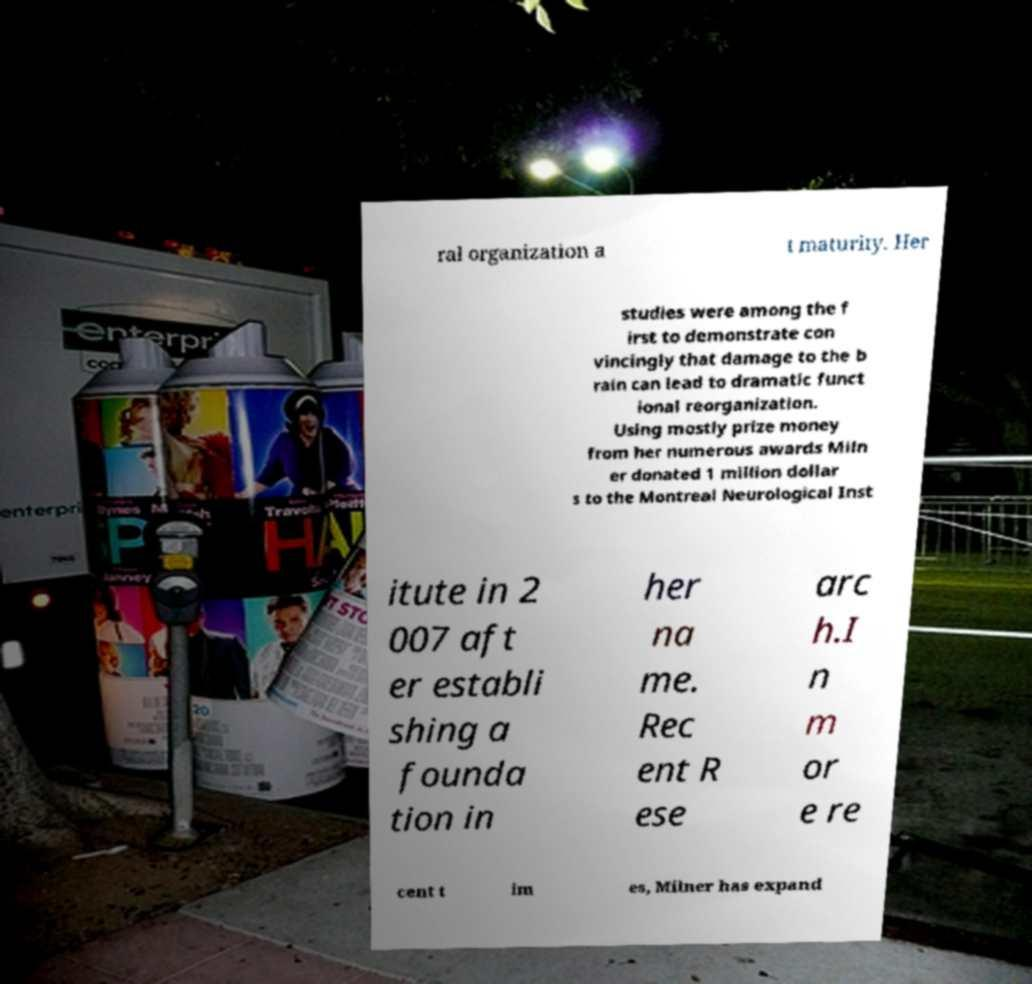Could you assist in decoding the text presented in this image and type it out clearly? ral organization a t maturity. Her studies were among the f irst to demonstrate con vincingly that damage to the b rain can lead to dramatic funct ional reorganization. Using mostly prize money from her numerous awards Miln er donated 1 million dollar s to the Montreal Neurological Inst itute in 2 007 aft er establi shing a founda tion in her na me. Rec ent R ese arc h.I n m or e re cent t im es, Milner has expand 